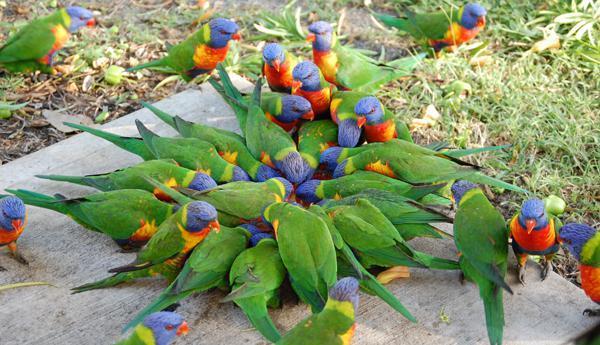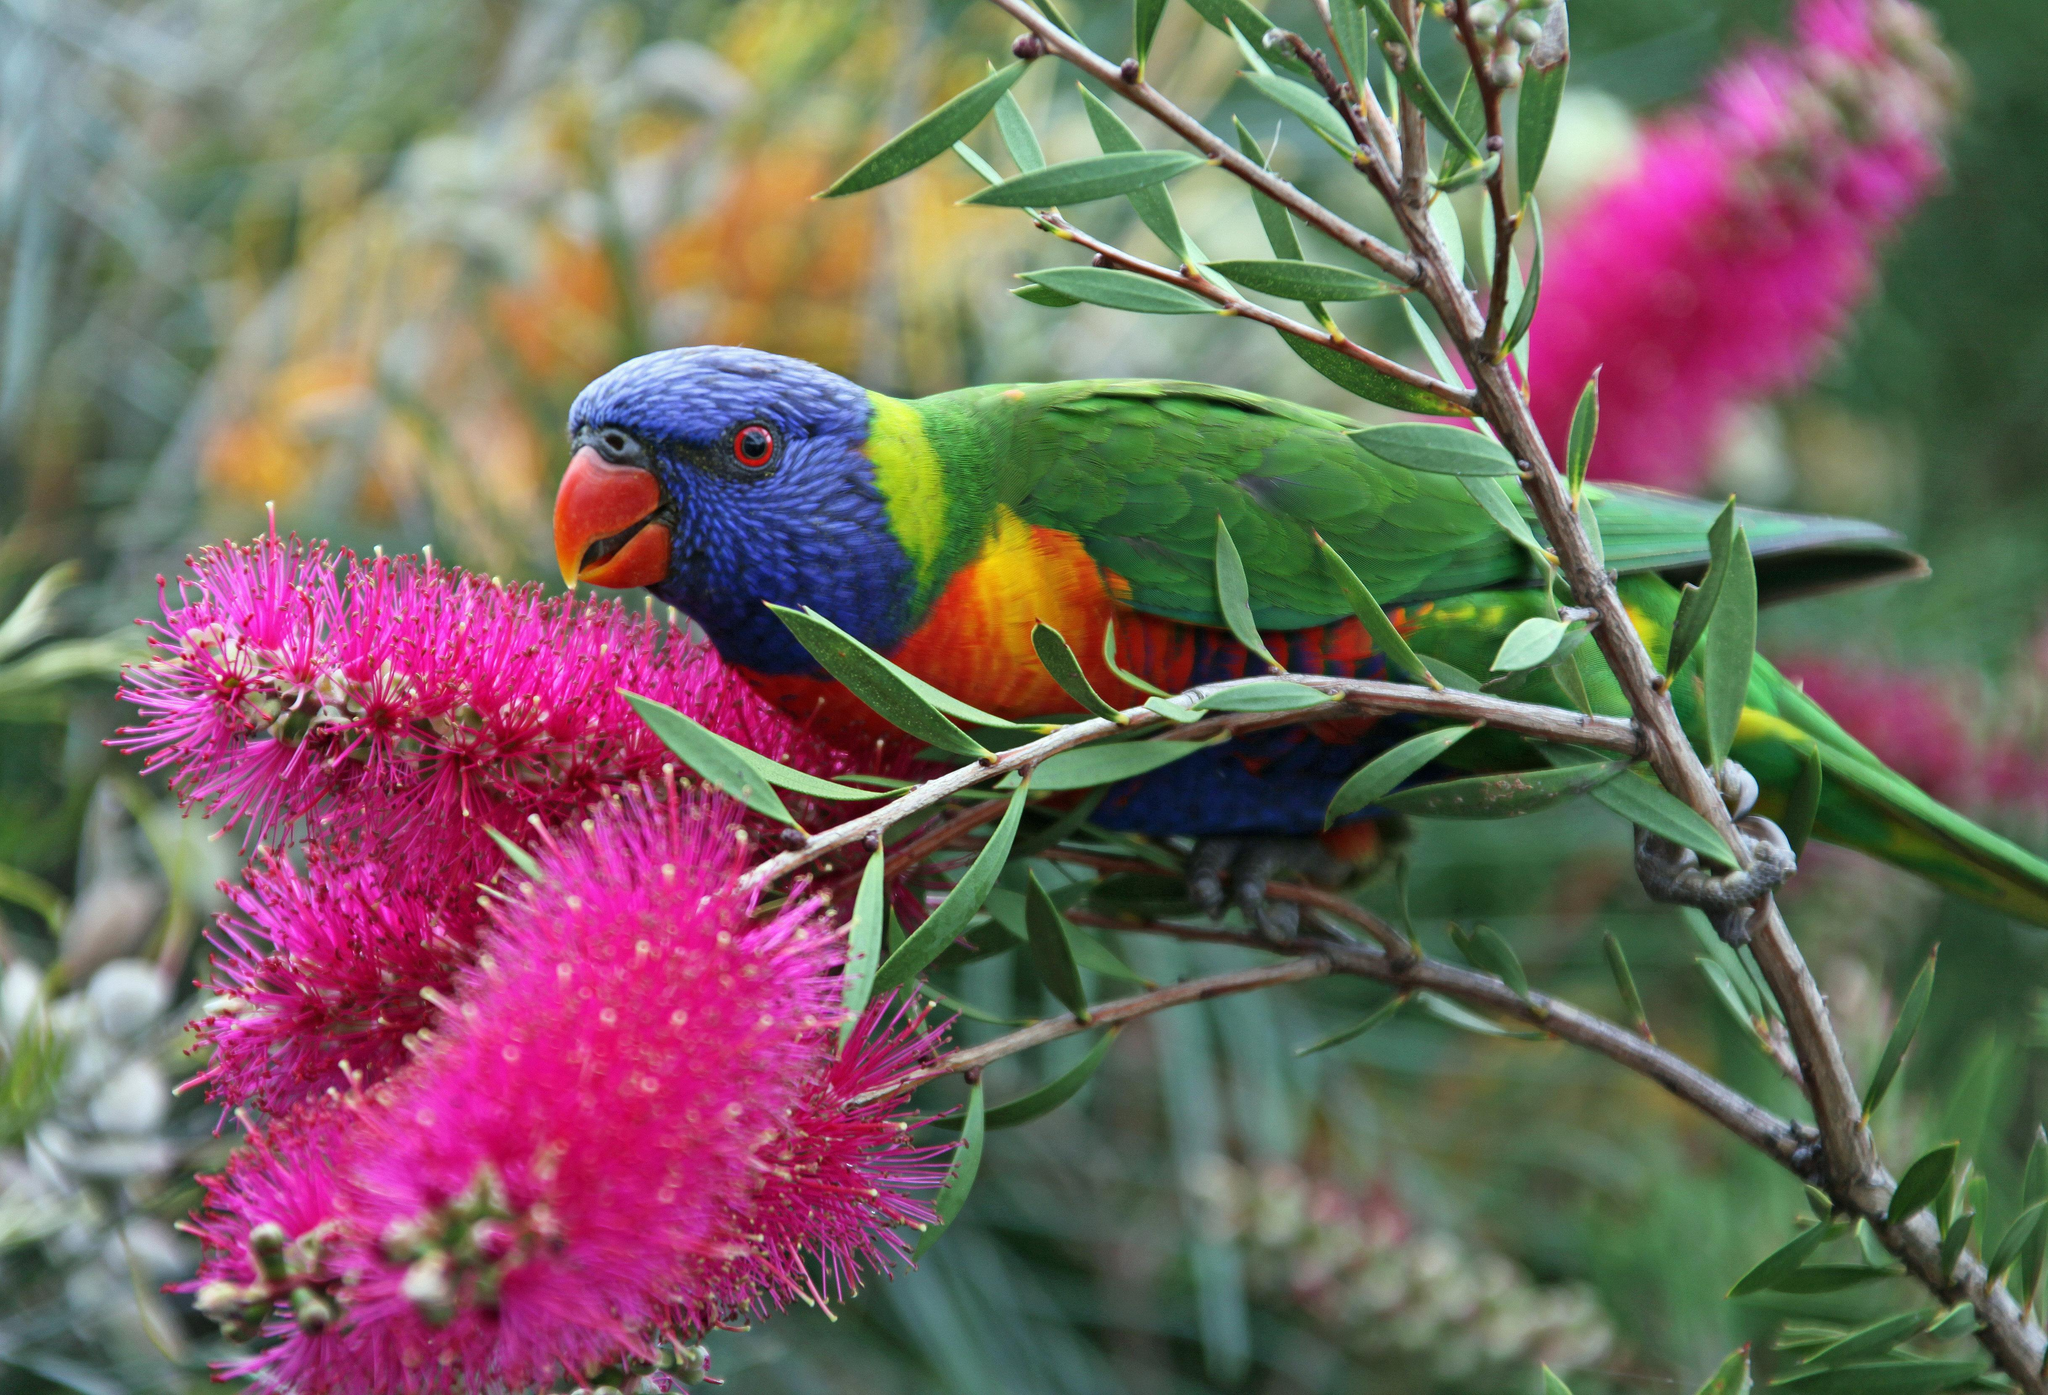The first image is the image on the left, the second image is the image on the right. Analyze the images presented: Is the assertion "An image contains a single colorful bird perched near hot pink flowers with tendril-like petals." valid? Answer yes or no. Yes. The first image is the image on the left, the second image is the image on the right. Given the left and right images, does the statement "In one of the images a colorful bird is sitting on a branch next to some bright pink flowers." hold true? Answer yes or no. Yes. 